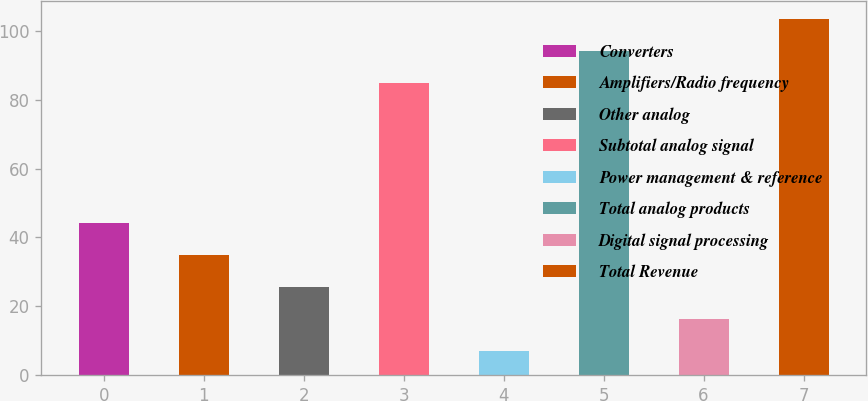<chart> <loc_0><loc_0><loc_500><loc_500><bar_chart><fcel>Converters<fcel>Amplifiers/Radio frequency<fcel>Other analog<fcel>Subtotal analog signal<fcel>Power management & reference<fcel>Total analog products<fcel>Digital signal processing<fcel>Total Revenue<nl><fcel>44.2<fcel>34.9<fcel>25.6<fcel>85<fcel>7<fcel>94.3<fcel>16.3<fcel>103.6<nl></chart> 